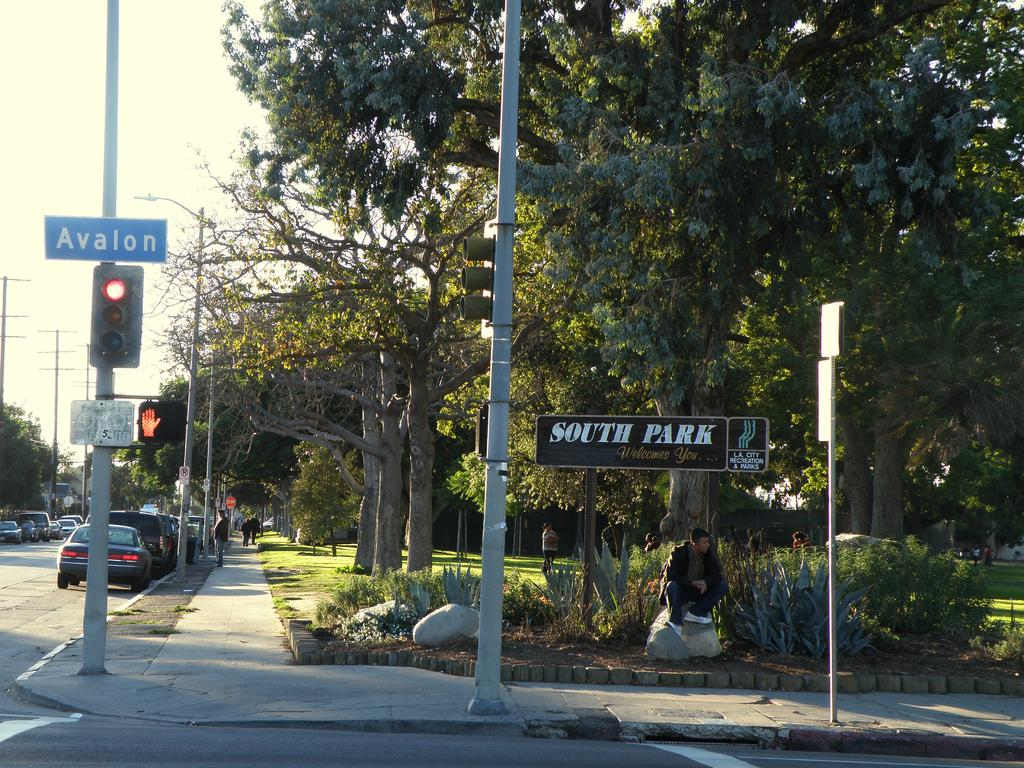<image>
Write a terse but informative summary of the picture. A person sits on a rock in front of a welcome to South Park sign. 